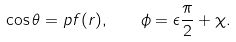Convert formula to latex. <formula><loc_0><loc_0><loc_500><loc_500>\cos \theta = p f ( r ) , \quad \phi = \epsilon \frac { \pi } { 2 } + \chi .</formula> 